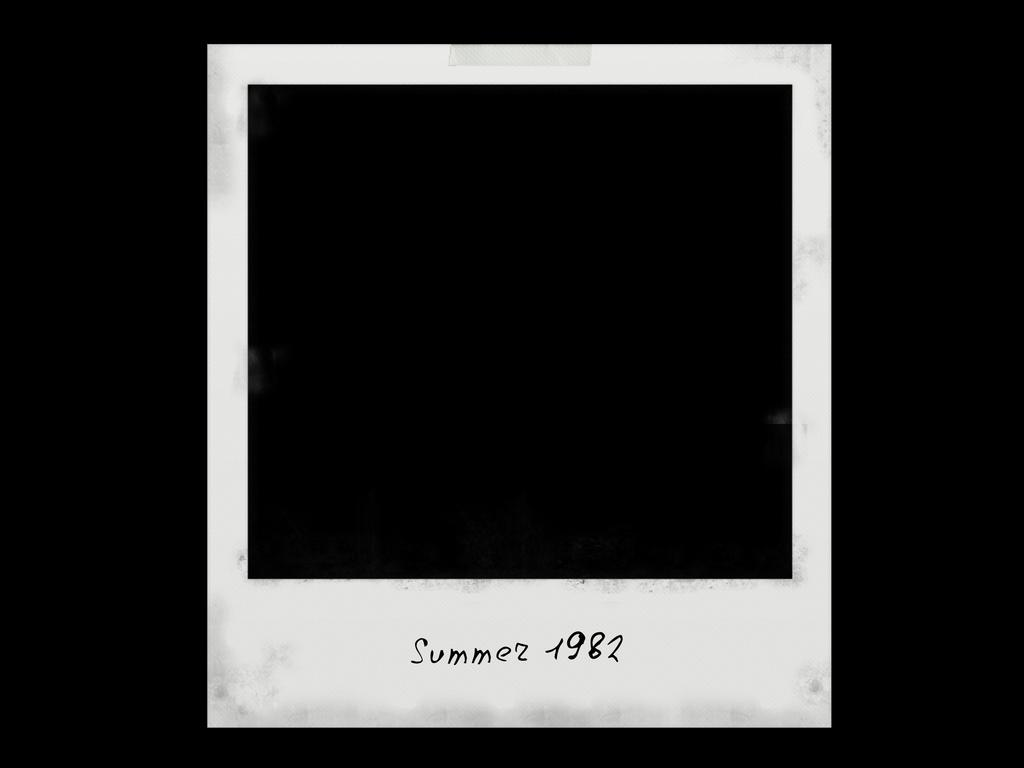<image>
Write a terse but informative summary of the picture. a blank white outlined image that reads summer 1982 